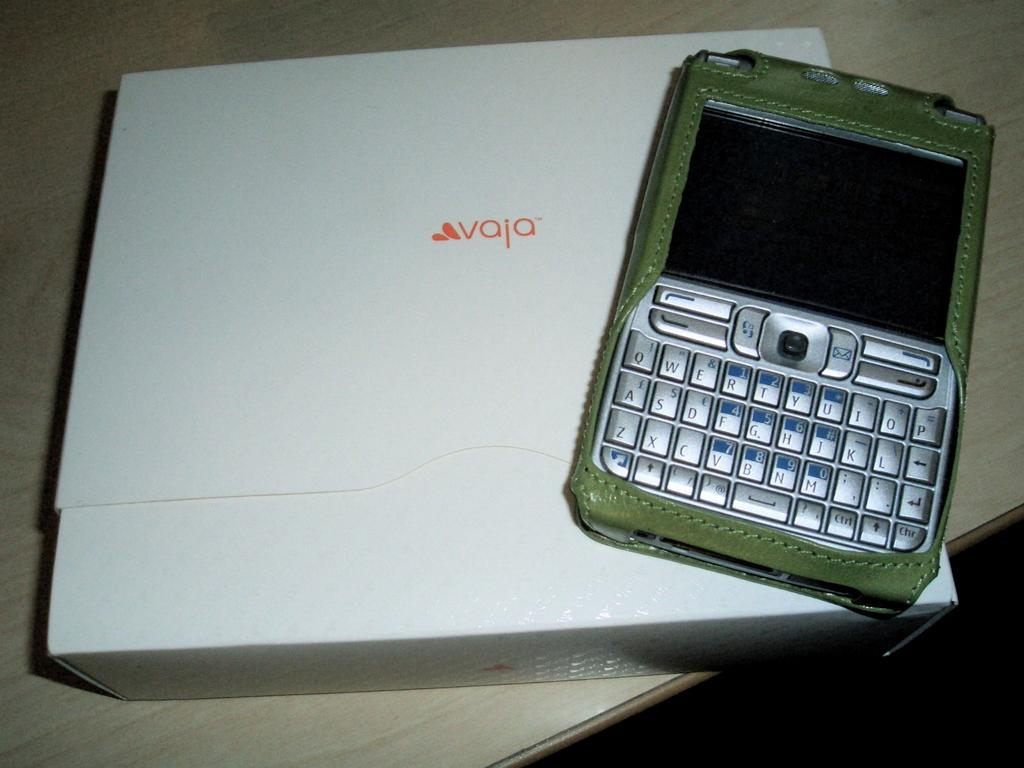<image>
Summarize the visual content of the image. An electronic device sitting on a white box with "Avaja" printed on the box. 